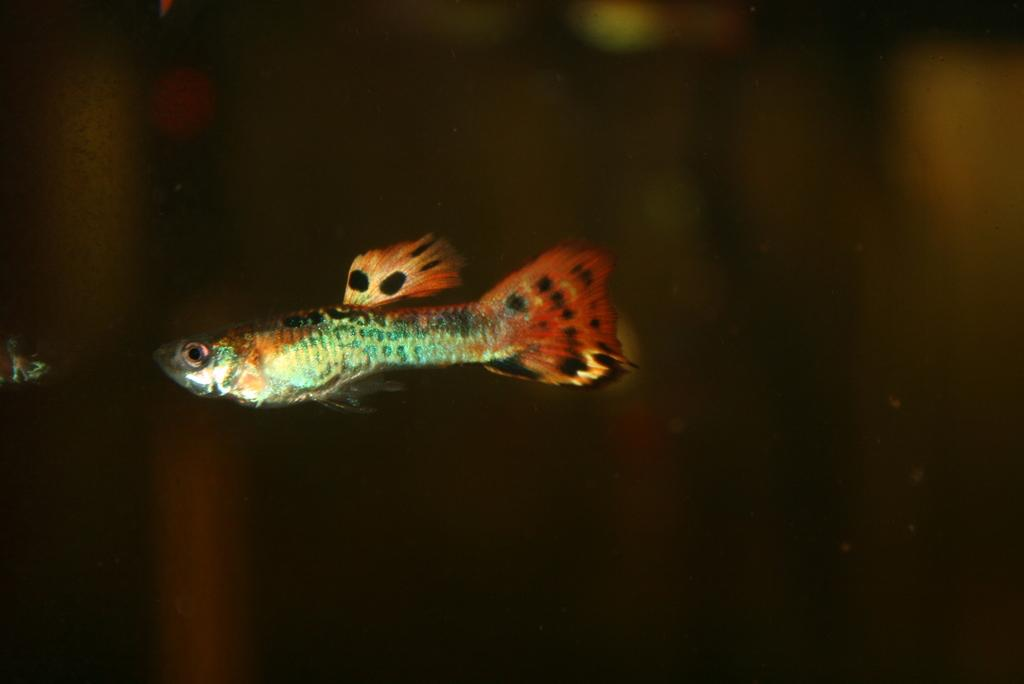What is the main subject of the image? There is a fish in the image. Where is the fish located in the image? The fish is on the left side of the image. What colors can be seen on the fish? The fish has orange and green colors. What type of wax can be seen melting on the fish's face in the image? There is no wax or face present on the fish in the image; it is a fish with orange and green colors. 